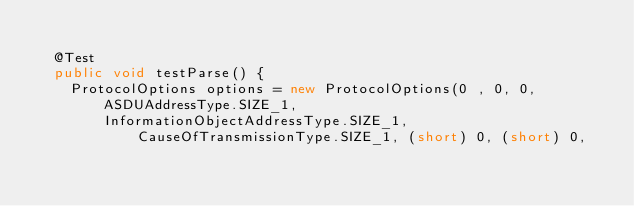<code> <loc_0><loc_0><loc_500><loc_500><_Java_>
	@Test
	public void testParse() {
		ProtocolOptions options = new ProtocolOptions(0 , 0, 0, ASDUAddressType.SIZE_1,
				InformationObjectAddressType.SIZE_1, CauseOfTransmissionType.SIZE_1, (short) 0, (short) 0,</code> 